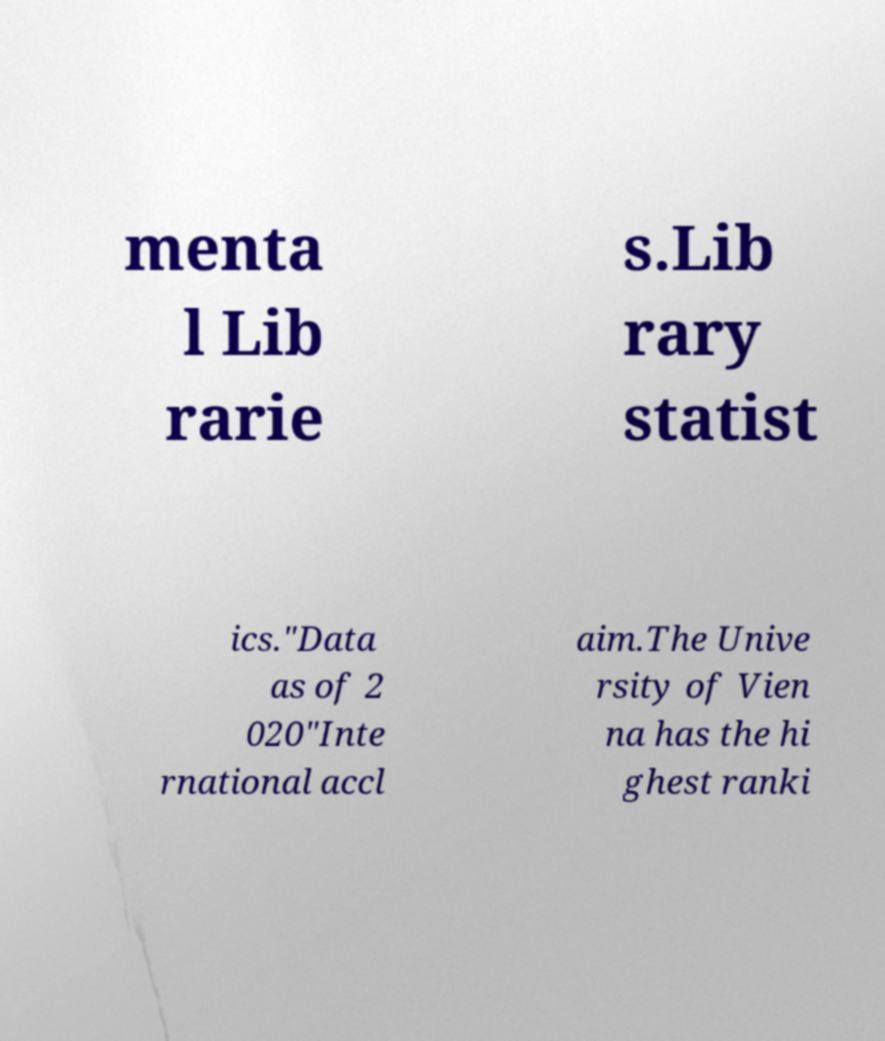Could you extract and type out the text from this image? menta l Lib rarie s.Lib rary statist ics."Data as of 2 020"Inte rnational accl aim.The Unive rsity of Vien na has the hi ghest ranki 